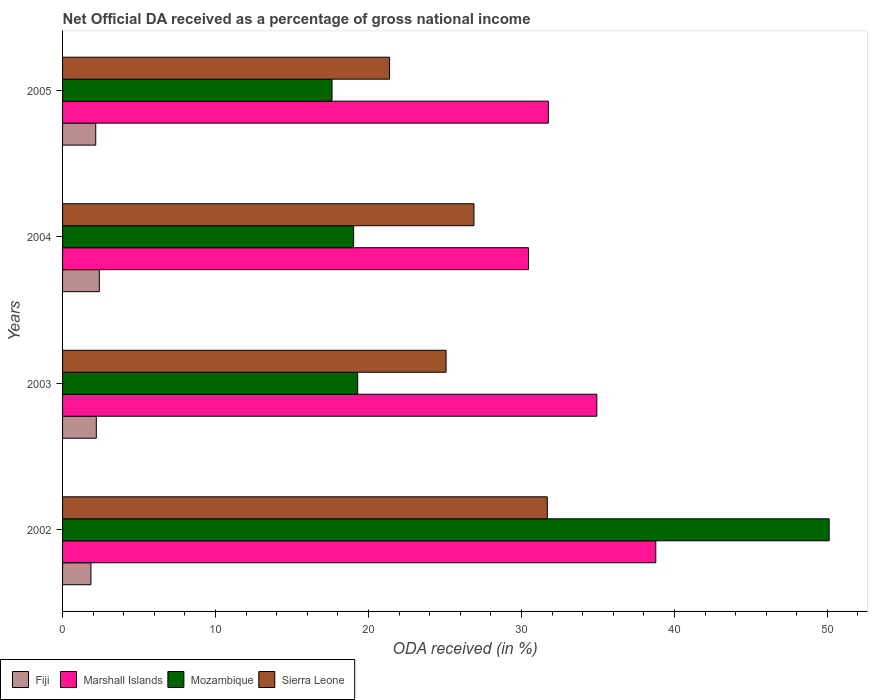How many different coloured bars are there?
Keep it short and to the point. 4. Are the number of bars per tick equal to the number of legend labels?
Your answer should be compact. Yes. What is the label of the 4th group of bars from the top?
Offer a very short reply. 2002. In how many cases, is the number of bars for a given year not equal to the number of legend labels?
Provide a succinct answer. 0. What is the net official DA received in Mozambique in 2005?
Ensure brevity in your answer.  17.61. Across all years, what is the maximum net official DA received in Marshall Islands?
Ensure brevity in your answer.  38.78. Across all years, what is the minimum net official DA received in Fiji?
Offer a terse response. 1.85. In which year was the net official DA received in Fiji maximum?
Offer a terse response. 2004. What is the total net official DA received in Sierra Leone in the graph?
Provide a succinct answer. 105.03. What is the difference between the net official DA received in Fiji in 2003 and that in 2004?
Keep it short and to the point. -0.2. What is the difference between the net official DA received in Mozambique in 2004 and the net official DA received in Marshall Islands in 2005?
Your answer should be compact. -12.74. What is the average net official DA received in Fiji per year?
Your response must be concise. 2.16. In the year 2002, what is the difference between the net official DA received in Mozambique and net official DA received in Sierra Leone?
Ensure brevity in your answer.  18.43. What is the ratio of the net official DA received in Mozambique in 2002 to that in 2005?
Offer a very short reply. 2.85. Is the net official DA received in Sierra Leone in 2002 less than that in 2004?
Provide a short and direct response. No. What is the difference between the highest and the second highest net official DA received in Fiji?
Your answer should be very brief. 0.2. What is the difference between the highest and the lowest net official DA received in Mozambique?
Your response must be concise. 32.5. Is it the case that in every year, the sum of the net official DA received in Marshall Islands and net official DA received in Fiji is greater than the sum of net official DA received in Mozambique and net official DA received in Sierra Leone?
Keep it short and to the point. No. What does the 4th bar from the top in 2005 represents?
Your response must be concise. Fiji. What does the 4th bar from the bottom in 2005 represents?
Make the answer very short. Sierra Leone. Is it the case that in every year, the sum of the net official DA received in Mozambique and net official DA received in Fiji is greater than the net official DA received in Marshall Islands?
Give a very brief answer. No. Are all the bars in the graph horizontal?
Your response must be concise. Yes. How many years are there in the graph?
Ensure brevity in your answer.  4. Does the graph contain any zero values?
Give a very brief answer. No. Does the graph contain grids?
Your response must be concise. No. Where does the legend appear in the graph?
Ensure brevity in your answer.  Bottom left. How many legend labels are there?
Offer a terse response. 4. What is the title of the graph?
Your answer should be compact. Net Official DA received as a percentage of gross national income. What is the label or title of the X-axis?
Offer a very short reply. ODA received (in %). What is the label or title of the Y-axis?
Give a very brief answer. Years. What is the ODA received (in %) of Fiji in 2002?
Provide a succinct answer. 1.85. What is the ODA received (in %) of Marshall Islands in 2002?
Give a very brief answer. 38.78. What is the ODA received (in %) of Mozambique in 2002?
Your response must be concise. 50.12. What is the ODA received (in %) in Sierra Leone in 2002?
Ensure brevity in your answer.  31.69. What is the ODA received (in %) in Fiji in 2003?
Offer a very short reply. 2.21. What is the ODA received (in %) of Marshall Islands in 2003?
Keep it short and to the point. 34.93. What is the ODA received (in %) in Mozambique in 2003?
Provide a succinct answer. 19.29. What is the ODA received (in %) of Sierra Leone in 2003?
Give a very brief answer. 25.07. What is the ODA received (in %) in Fiji in 2004?
Make the answer very short. 2.4. What is the ODA received (in %) of Marshall Islands in 2004?
Offer a very short reply. 30.46. What is the ODA received (in %) in Mozambique in 2004?
Your response must be concise. 19.03. What is the ODA received (in %) of Sierra Leone in 2004?
Your answer should be very brief. 26.89. What is the ODA received (in %) of Fiji in 2005?
Offer a very short reply. 2.17. What is the ODA received (in %) of Marshall Islands in 2005?
Offer a very short reply. 31.76. What is the ODA received (in %) of Mozambique in 2005?
Offer a terse response. 17.61. What is the ODA received (in %) in Sierra Leone in 2005?
Your answer should be compact. 21.38. Across all years, what is the maximum ODA received (in %) in Fiji?
Your response must be concise. 2.4. Across all years, what is the maximum ODA received (in %) of Marshall Islands?
Your answer should be very brief. 38.78. Across all years, what is the maximum ODA received (in %) of Mozambique?
Make the answer very short. 50.12. Across all years, what is the maximum ODA received (in %) in Sierra Leone?
Your response must be concise. 31.69. Across all years, what is the minimum ODA received (in %) in Fiji?
Keep it short and to the point. 1.85. Across all years, what is the minimum ODA received (in %) in Marshall Islands?
Provide a short and direct response. 30.46. Across all years, what is the minimum ODA received (in %) of Mozambique?
Provide a succinct answer. 17.61. Across all years, what is the minimum ODA received (in %) of Sierra Leone?
Provide a succinct answer. 21.38. What is the total ODA received (in %) in Fiji in the graph?
Your response must be concise. 8.63. What is the total ODA received (in %) in Marshall Islands in the graph?
Offer a very short reply. 135.93. What is the total ODA received (in %) of Mozambique in the graph?
Offer a very short reply. 106.05. What is the total ODA received (in %) in Sierra Leone in the graph?
Make the answer very short. 105.03. What is the difference between the ODA received (in %) in Fiji in 2002 and that in 2003?
Keep it short and to the point. -0.35. What is the difference between the ODA received (in %) of Marshall Islands in 2002 and that in 2003?
Your answer should be very brief. 3.85. What is the difference between the ODA received (in %) in Mozambique in 2002 and that in 2003?
Your response must be concise. 30.82. What is the difference between the ODA received (in %) of Sierra Leone in 2002 and that in 2003?
Make the answer very short. 6.62. What is the difference between the ODA received (in %) of Fiji in 2002 and that in 2004?
Provide a succinct answer. -0.55. What is the difference between the ODA received (in %) of Marshall Islands in 2002 and that in 2004?
Your response must be concise. 8.32. What is the difference between the ODA received (in %) of Mozambique in 2002 and that in 2004?
Ensure brevity in your answer.  31.09. What is the difference between the ODA received (in %) of Sierra Leone in 2002 and that in 2004?
Give a very brief answer. 4.79. What is the difference between the ODA received (in %) of Fiji in 2002 and that in 2005?
Ensure brevity in your answer.  -0.32. What is the difference between the ODA received (in %) of Marshall Islands in 2002 and that in 2005?
Make the answer very short. 7.02. What is the difference between the ODA received (in %) of Mozambique in 2002 and that in 2005?
Make the answer very short. 32.5. What is the difference between the ODA received (in %) of Sierra Leone in 2002 and that in 2005?
Make the answer very short. 10.31. What is the difference between the ODA received (in %) of Fiji in 2003 and that in 2004?
Make the answer very short. -0.2. What is the difference between the ODA received (in %) of Marshall Islands in 2003 and that in 2004?
Ensure brevity in your answer.  4.47. What is the difference between the ODA received (in %) of Mozambique in 2003 and that in 2004?
Make the answer very short. 0.27. What is the difference between the ODA received (in %) of Sierra Leone in 2003 and that in 2004?
Your answer should be very brief. -1.82. What is the difference between the ODA received (in %) in Fiji in 2003 and that in 2005?
Your response must be concise. 0.04. What is the difference between the ODA received (in %) of Marshall Islands in 2003 and that in 2005?
Keep it short and to the point. 3.16. What is the difference between the ODA received (in %) of Mozambique in 2003 and that in 2005?
Provide a succinct answer. 1.68. What is the difference between the ODA received (in %) in Sierra Leone in 2003 and that in 2005?
Make the answer very short. 3.7. What is the difference between the ODA received (in %) of Fiji in 2004 and that in 2005?
Provide a succinct answer. 0.23. What is the difference between the ODA received (in %) in Marshall Islands in 2004 and that in 2005?
Keep it short and to the point. -1.31. What is the difference between the ODA received (in %) in Mozambique in 2004 and that in 2005?
Give a very brief answer. 1.41. What is the difference between the ODA received (in %) in Sierra Leone in 2004 and that in 2005?
Give a very brief answer. 5.52. What is the difference between the ODA received (in %) of Fiji in 2002 and the ODA received (in %) of Marshall Islands in 2003?
Give a very brief answer. -33.07. What is the difference between the ODA received (in %) of Fiji in 2002 and the ODA received (in %) of Mozambique in 2003?
Offer a terse response. -17.44. What is the difference between the ODA received (in %) of Fiji in 2002 and the ODA received (in %) of Sierra Leone in 2003?
Offer a terse response. -23.22. What is the difference between the ODA received (in %) in Marshall Islands in 2002 and the ODA received (in %) in Mozambique in 2003?
Ensure brevity in your answer.  19.49. What is the difference between the ODA received (in %) of Marshall Islands in 2002 and the ODA received (in %) of Sierra Leone in 2003?
Your answer should be compact. 13.71. What is the difference between the ODA received (in %) in Mozambique in 2002 and the ODA received (in %) in Sierra Leone in 2003?
Your response must be concise. 25.04. What is the difference between the ODA received (in %) of Fiji in 2002 and the ODA received (in %) of Marshall Islands in 2004?
Offer a very short reply. -28.61. What is the difference between the ODA received (in %) in Fiji in 2002 and the ODA received (in %) in Mozambique in 2004?
Provide a succinct answer. -17.17. What is the difference between the ODA received (in %) of Fiji in 2002 and the ODA received (in %) of Sierra Leone in 2004?
Your response must be concise. -25.04. What is the difference between the ODA received (in %) in Marshall Islands in 2002 and the ODA received (in %) in Mozambique in 2004?
Provide a short and direct response. 19.75. What is the difference between the ODA received (in %) in Marshall Islands in 2002 and the ODA received (in %) in Sierra Leone in 2004?
Make the answer very short. 11.89. What is the difference between the ODA received (in %) of Mozambique in 2002 and the ODA received (in %) of Sierra Leone in 2004?
Your answer should be compact. 23.22. What is the difference between the ODA received (in %) of Fiji in 2002 and the ODA received (in %) of Marshall Islands in 2005?
Your answer should be compact. -29.91. What is the difference between the ODA received (in %) of Fiji in 2002 and the ODA received (in %) of Mozambique in 2005?
Keep it short and to the point. -15.76. What is the difference between the ODA received (in %) of Fiji in 2002 and the ODA received (in %) of Sierra Leone in 2005?
Make the answer very short. -19.52. What is the difference between the ODA received (in %) in Marshall Islands in 2002 and the ODA received (in %) in Mozambique in 2005?
Keep it short and to the point. 21.17. What is the difference between the ODA received (in %) of Marshall Islands in 2002 and the ODA received (in %) of Sierra Leone in 2005?
Keep it short and to the point. 17.41. What is the difference between the ODA received (in %) of Mozambique in 2002 and the ODA received (in %) of Sierra Leone in 2005?
Make the answer very short. 28.74. What is the difference between the ODA received (in %) in Fiji in 2003 and the ODA received (in %) in Marshall Islands in 2004?
Keep it short and to the point. -28.25. What is the difference between the ODA received (in %) of Fiji in 2003 and the ODA received (in %) of Mozambique in 2004?
Your response must be concise. -16.82. What is the difference between the ODA received (in %) in Fiji in 2003 and the ODA received (in %) in Sierra Leone in 2004?
Provide a short and direct response. -24.69. What is the difference between the ODA received (in %) of Marshall Islands in 2003 and the ODA received (in %) of Mozambique in 2004?
Your response must be concise. 15.9. What is the difference between the ODA received (in %) of Marshall Islands in 2003 and the ODA received (in %) of Sierra Leone in 2004?
Your answer should be very brief. 8.03. What is the difference between the ODA received (in %) in Mozambique in 2003 and the ODA received (in %) in Sierra Leone in 2004?
Provide a short and direct response. -7.6. What is the difference between the ODA received (in %) of Fiji in 2003 and the ODA received (in %) of Marshall Islands in 2005?
Your answer should be compact. -29.56. What is the difference between the ODA received (in %) in Fiji in 2003 and the ODA received (in %) in Mozambique in 2005?
Make the answer very short. -15.41. What is the difference between the ODA received (in %) in Fiji in 2003 and the ODA received (in %) in Sierra Leone in 2005?
Give a very brief answer. -19.17. What is the difference between the ODA received (in %) in Marshall Islands in 2003 and the ODA received (in %) in Mozambique in 2005?
Give a very brief answer. 17.31. What is the difference between the ODA received (in %) in Marshall Islands in 2003 and the ODA received (in %) in Sierra Leone in 2005?
Offer a very short reply. 13.55. What is the difference between the ODA received (in %) of Mozambique in 2003 and the ODA received (in %) of Sierra Leone in 2005?
Ensure brevity in your answer.  -2.08. What is the difference between the ODA received (in %) in Fiji in 2004 and the ODA received (in %) in Marshall Islands in 2005?
Your answer should be compact. -29.36. What is the difference between the ODA received (in %) in Fiji in 2004 and the ODA received (in %) in Mozambique in 2005?
Keep it short and to the point. -15.21. What is the difference between the ODA received (in %) in Fiji in 2004 and the ODA received (in %) in Sierra Leone in 2005?
Your answer should be very brief. -18.97. What is the difference between the ODA received (in %) of Marshall Islands in 2004 and the ODA received (in %) of Mozambique in 2005?
Offer a terse response. 12.84. What is the difference between the ODA received (in %) in Marshall Islands in 2004 and the ODA received (in %) in Sierra Leone in 2005?
Make the answer very short. 9.08. What is the difference between the ODA received (in %) in Mozambique in 2004 and the ODA received (in %) in Sierra Leone in 2005?
Offer a terse response. -2.35. What is the average ODA received (in %) of Fiji per year?
Your answer should be very brief. 2.16. What is the average ODA received (in %) of Marshall Islands per year?
Make the answer very short. 33.98. What is the average ODA received (in %) of Mozambique per year?
Give a very brief answer. 26.51. What is the average ODA received (in %) in Sierra Leone per year?
Your answer should be very brief. 26.26. In the year 2002, what is the difference between the ODA received (in %) of Fiji and ODA received (in %) of Marshall Islands?
Your answer should be very brief. -36.93. In the year 2002, what is the difference between the ODA received (in %) in Fiji and ODA received (in %) in Mozambique?
Keep it short and to the point. -48.26. In the year 2002, what is the difference between the ODA received (in %) in Fiji and ODA received (in %) in Sierra Leone?
Give a very brief answer. -29.84. In the year 2002, what is the difference between the ODA received (in %) of Marshall Islands and ODA received (in %) of Mozambique?
Your answer should be very brief. -11.33. In the year 2002, what is the difference between the ODA received (in %) of Marshall Islands and ODA received (in %) of Sierra Leone?
Your answer should be very brief. 7.09. In the year 2002, what is the difference between the ODA received (in %) of Mozambique and ODA received (in %) of Sierra Leone?
Provide a short and direct response. 18.43. In the year 2003, what is the difference between the ODA received (in %) of Fiji and ODA received (in %) of Marshall Islands?
Keep it short and to the point. -32.72. In the year 2003, what is the difference between the ODA received (in %) in Fiji and ODA received (in %) in Mozambique?
Give a very brief answer. -17.09. In the year 2003, what is the difference between the ODA received (in %) in Fiji and ODA received (in %) in Sierra Leone?
Ensure brevity in your answer.  -22.87. In the year 2003, what is the difference between the ODA received (in %) in Marshall Islands and ODA received (in %) in Mozambique?
Offer a very short reply. 15.63. In the year 2003, what is the difference between the ODA received (in %) of Marshall Islands and ODA received (in %) of Sierra Leone?
Ensure brevity in your answer.  9.86. In the year 2003, what is the difference between the ODA received (in %) in Mozambique and ODA received (in %) in Sierra Leone?
Ensure brevity in your answer.  -5.78. In the year 2004, what is the difference between the ODA received (in %) of Fiji and ODA received (in %) of Marshall Islands?
Your answer should be very brief. -28.05. In the year 2004, what is the difference between the ODA received (in %) of Fiji and ODA received (in %) of Mozambique?
Your response must be concise. -16.62. In the year 2004, what is the difference between the ODA received (in %) in Fiji and ODA received (in %) in Sierra Leone?
Keep it short and to the point. -24.49. In the year 2004, what is the difference between the ODA received (in %) of Marshall Islands and ODA received (in %) of Mozambique?
Give a very brief answer. 11.43. In the year 2004, what is the difference between the ODA received (in %) of Marshall Islands and ODA received (in %) of Sierra Leone?
Offer a terse response. 3.56. In the year 2004, what is the difference between the ODA received (in %) of Mozambique and ODA received (in %) of Sierra Leone?
Make the answer very short. -7.87. In the year 2005, what is the difference between the ODA received (in %) of Fiji and ODA received (in %) of Marshall Islands?
Provide a short and direct response. -29.59. In the year 2005, what is the difference between the ODA received (in %) of Fiji and ODA received (in %) of Mozambique?
Offer a terse response. -15.45. In the year 2005, what is the difference between the ODA received (in %) in Fiji and ODA received (in %) in Sierra Leone?
Offer a terse response. -19.21. In the year 2005, what is the difference between the ODA received (in %) of Marshall Islands and ODA received (in %) of Mozambique?
Give a very brief answer. 14.15. In the year 2005, what is the difference between the ODA received (in %) in Marshall Islands and ODA received (in %) in Sierra Leone?
Provide a short and direct response. 10.39. In the year 2005, what is the difference between the ODA received (in %) in Mozambique and ODA received (in %) in Sierra Leone?
Give a very brief answer. -3.76. What is the ratio of the ODA received (in %) in Fiji in 2002 to that in 2003?
Give a very brief answer. 0.84. What is the ratio of the ODA received (in %) of Marshall Islands in 2002 to that in 2003?
Your response must be concise. 1.11. What is the ratio of the ODA received (in %) of Mozambique in 2002 to that in 2003?
Offer a very short reply. 2.6. What is the ratio of the ODA received (in %) in Sierra Leone in 2002 to that in 2003?
Give a very brief answer. 1.26. What is the ratio of the ODA received (in %) of Fiji in 2002 to that in 2004?
Provide a succinct answer. 0.77. What is the ratio of the ODA received (in %) of Marshall Islands in 2002 to that in 2004?
Make the answer very short. 1.27. What is the ratio of the ODA received (in %) of Mozambique in 2002 to that in 2004?
Keep it short and to the point. 2.63. What is the ratio of the ODA received (in %) in Sierra Leone in 2002 to that in 2004?
Keep it short and to the point. 1.18. What is the ratio of the ODA received (in %) of Fiji in 2002 to that in 2005?
Give a very brief answer. 0.85. What is the ratio of the ODA received (in %) in Marshall Islands in 2002 to that in 2005?
Provide a succinct answer. 1.22. What is the ratio of the ODA received (in %) of Mozambique in 2002 to that in 2005?
Keep it short and to the point. 2.85. What is the ratio of the ODA received (in %) in Sierra Leone in 2002 to that in 2005?
Offer a terse response. 1.48. What is the ratio of the ODA received (in %) in Fiji in 2003 to that in 2004?
Your answer should be very brief. 0.92. What is the ratio of the ODA received (in %) in Marshall Islands in 2003 to that in 2004?
Make the answer very short. 1.15. What is the ratio of the ODA received (in %) of Mozambique in 2003 to that in 2004?
Offer a terse response. 1.01. What is the ratio of the ODA received (in %) of Sierra Leone in 2003 to that in 2004?
Offer a terse response. 0.93. What is the ratio of the ODA received (in %) of Fiji in 2003 to that in 2005?
Provide a short and direct response. 1.02. What is the ratio of the ODA received (in %) in Marshall Islands in 2003 to that in 2005?
Make the answer very short. 1.1. What is the ratio of the ODA received (in %) of Mozambique in 2003 to that in 2005?
Offer a very short reply. 1.1. What is the ratio of the ODA received (in %) of Sierra Leone in 2003 to that in 2005?
Keep it short and to the point. 1.17. What is the ratio of the ODA received (in %) in Fiji in 2004 to that in 2005?
Provide a short and direct response. 1.11. What is the ratio of the ODA received (in %) in Marshall Islands in 2004 to that in 2005?
Your answer should be compact. 0.96. What is the ratio of the ODA received (in %) of Mozambique in 2004 to that in 2005?
Your answer should be compact. 1.08. What is the ratio of the ODA received (in %) of Sierra Leone in 2004 to that in 2005?
Your answer should be very brief. 1.26. What is the difference between the highest and the second highest ODA received (in %) of Fiji?
Keep it short and to the point. 0.2. What is the difference between the highest and the second highest ODA received (in %) of Marshall Islands?
Offer a terse response. 3.85. What is the difference between the highest and the second highest ODA received (in %) of Mozambique?
Your answer should be very brief. 30.82. What is the difference between the highest and the second highest ODA received (in %) of Sierra Leone?
Ensure brevity in your answer.  4.79. What is the difference between the highest and the lowest ODA received (in %) of Fiji?
Your response must be concise. 0.55. What is the difference between the highest and the lowest ODA received (in %) of Marshall Islands?
Give a very brief answer. 8.32. What is the difference between the highest and the lowest ODA received (in %) of Mozambique?
Keep it short and to the point. 32.5. What is the difference between the highest and the lowest ODA received (in %) in Sierra Leone?
Offer a very short reply. 10.31. 